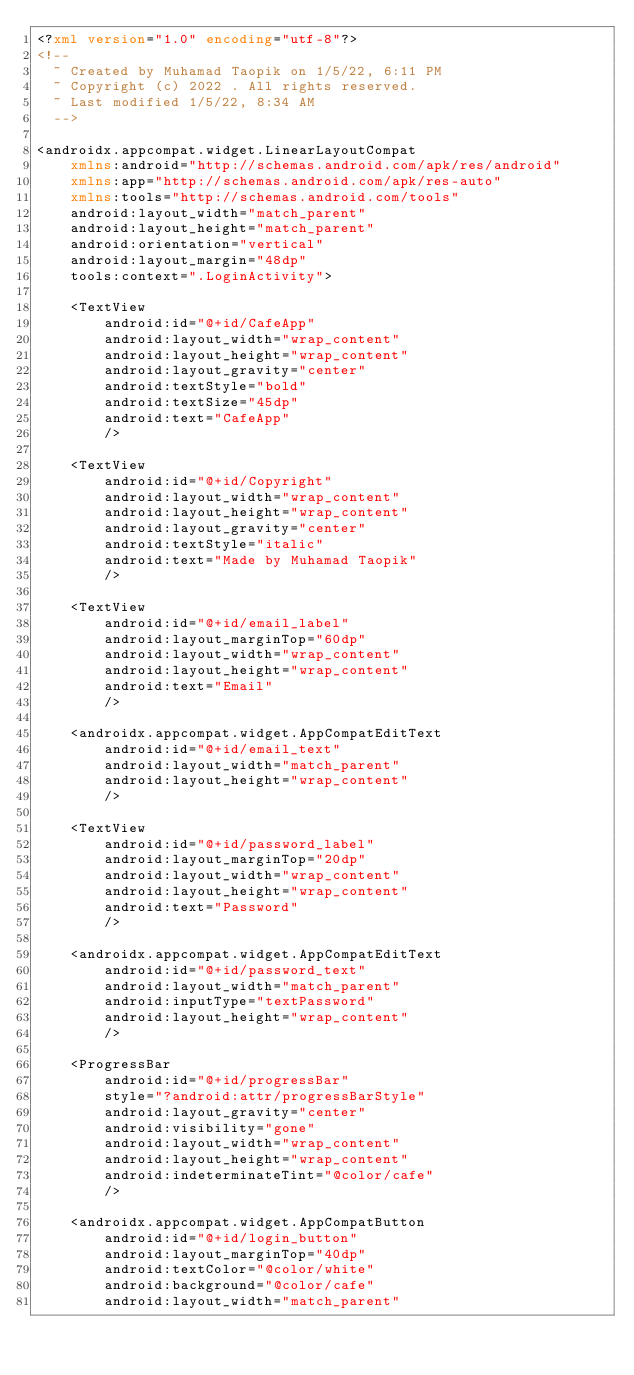<code> <loc_0><loc_0><loc_500><loc_500><_XML_><?xml version="1.0" encoding="utf-8"?>
<!--
  ~ Created by Muhamad Taopik on 1/5/22, 6:11 PM
  ~ Copyright (c) 2022 . All rights reserved.
  ~ Last modified 1/5/22, 8:34 AM
  -->

<androidx.appcompat.widget.LinearLayoutCompat
    xmlns:android="http://schemas.android.com/apk/res/android"
    xmlns:app="http://schemas.android.com/apk/res-auto"
    xmlns:tools="http://schemas.android.com/tools"
    android:layout_width="match_parent"
    android:layout_height="match_parent"
    android:orientation="vertical"
    android:layout_margin="48dp"
    tools:context=".LoginActivity">

    <TextView
        android:id="@+id/CafeApp"
        android:layout_width="wrap_content"
        android:layout_height="wrap_content"
        android:layout_gravity="center"
        android:textStyle="bold"
        android:textSize="45dp"
        android:text="CafeApp"
        />

    <TextView
        android:id="@+id/Copyright"
        android:layout_width="wrap_content"
        android:layout_height="wrap_content"
        android:layout_gravity="center"
        android:textStyle="italic"
        android:text="Made by Muhamad Taopik"
        />

    <TextView
        android:id="@+id/email_label"
        android:layout_marginTop="60dp"
        android:layout_width="wrap_content"
        android:layout_height="wrap_content"
        android:text="Email"
        />

    <androidx.appcompat.widget.AppCompatEditText
        android:id="@+id/email_text"
        android:layout_width="match_parent"
        android:layout_height="wrap_content"
        />

    <TextView
        android:id="@+id/password_label"
        android:layout_marginTop="20dp"
        android:layout_width="wrap_content"
        android:layout_height="wrap_content"
        android:text="Password"
        />

    <androidx.appcompat.widget.AppCompatEditText
        android:id="@+id/password_text"
        android:layout_width="match_parent"
        android:inputType="textPassword"
        android:layout_height="wrap_content"
        />

    <ProgressBar
        android:id="@+id/progressBar"
        style="?android:attr/progressBarStyle"
        android:layout_gravity="center"
        android:visibility="gone"
        android:layout_width="wrap_content"
        android:layout_height="wrap_content"
        android:indeterminateTint="@color/cafe"
        />

    <androidx.appcompat.widget.AppCompatButton
        android:id="@+id/login_button"
        android:layout_marginTop="40dp"
        android:textColor="@color/white"
        android:background="@color/cafe"
        android:layout_width="match_parent"</code> 